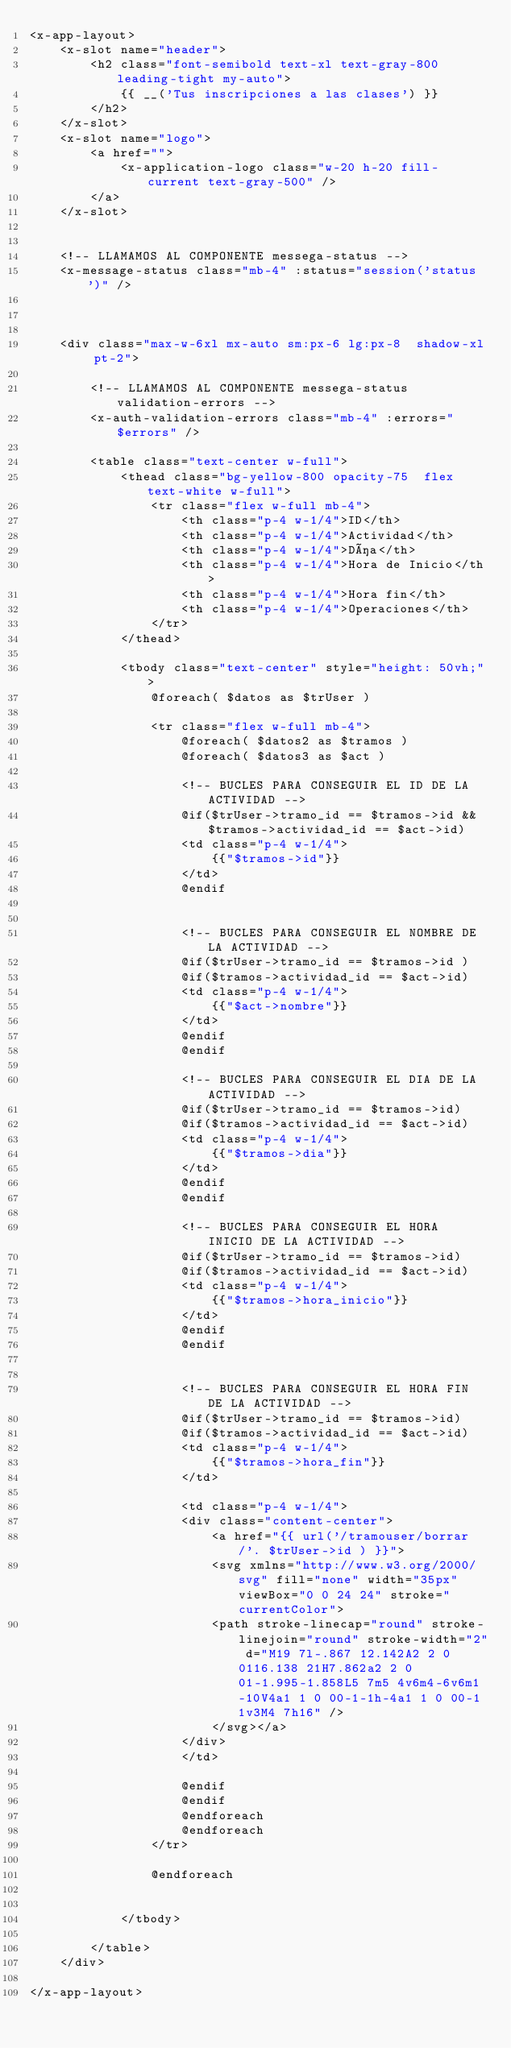Convert code to text. <code><loc_0><loc_0><loc_500><loc_500><_PHP_><x-app-layout>
    <x-slot name="header">
        <h2 class="font-semibold text-xl text-gray-800 leading-tight my-auto">
            {{ __('Tus inscripciones a las clases') }}
        </h2>
    </x-slot>
    <x-slot name="logo">
        <a href="">
            <x-application-logo class="w-20 h-20 fill-current text-gray-500" />
        </a>
    </x-slot>


    <!-- LLAMAMOS AL COMPONENTE messega-status -->
    <x-message-status class="mb-4" :status="session('status')" />
    
    

    <div class="max-w-6xl mx-auto sm:px-6 lg:px-8  shadow-xl pt-2">

        <!-- LLAMAMOS AL COMPONENTE messega-status validation-errors -->
        <x-auth-validation-errors class="mb-4" :errors="$errors" />

        <table class="text-center w-full">
            <thead class="bg-yellow-800 opacity-75  flex text-white w-full">
                <tr class="flex w-full mb-4">
                    <th class="p-4 w-1/4">ID</th>
                    <th class="p-4 w-1/4">Actividad</th>
                    <th class="p-4 w-1/4">Día</th>
                    <th class="p-4 w-1/4">Hora de Inicio</th>
                    <th class="p-4 w-1/4">Hora fin</th>
                    <th class="p-4 w-1/4">Operaciones</th>
                </tr>
            </thead>
            
            <tbody class="text-center" style="height: 50vh;">
                @foreach( $datos as $trUser )
                
                <tr class="flex w-full mb-4">
                    @foreach( $datos2 as $tramos )
                    @foreach( $datos3 as $act )

                    <!-- BUCLES PARA CONSEGUIR EL ID DE LA ACTIVIDAD -->
                    @if($trUser->tramo_id == $tramos->id && $tramos->actividad_id == $act->id)
                    <td class="p-4 w-1/4">
                        {{"$tramos->id"}}
                    </td>
                    @endif


                    <!-- BUCLES PARA CONSEGUIR EL NOMBRE DE LA ACTIVIDAD -->
                    @if($trUser->tramo_id == $tramos->id )
                    @if($tramos->actividad_id == $act->id)
                    <td class="p-4 w-1/4">
                        {{"$act->nombre"}}
                    </td>
                    @endif
                    @endif

                    <!-- BUCLES PARA CONSEGUIR EL DIA DE LA ACTIVIDAD -->
                    @if($trUser->tramo_id == $tramos->id)
                    @if($tramos->actividad_id == $act->id)
                    <td class="p-4 w-1/4">
                        {{"$tramos->dia"}}
                    </td>
                    @endif
                    @endif

                    <!-- BUCLES PARA CONSEGUIR EL HORA INICIO DE LA ACTIVIDAD -->
                    @if($trUser->tramo_id == $tramos->id)
                    @if($tramos->actividad_id == $act->id)
                    <td class="p-4 w-1/4">
                        {{"$tramos->hora_inicio"}}
                    </td>
                    @endif
                    @endif


                    <!-- BUCLES PARA CONSEGUIR EL HORA FIN DE LA ACTIVIDAD -->
                    @if($trUser->tramo_id == $tramos->id)
                    @if($tramos->actividad_id == $act->id)
                    <td class="p-4 w-1/4">
                        {{"$tramos->hora_fin"}}
                    </td>

                    <td class="p-4 w-1/4">
                    <div class="content-center">
                        <a href="{{ url('/tramouser/borrar/'. $trUser->id ) }}">
                        <svg xmlns="http://www.w3.org/2000/svg" fill="none" width="35px" viewBox="0 0 24 24" stroke="currentColor">
                        <path stroke-linecap="round" stroke-linejoin="round" stroke-width="2" d="M19 7l-.867 12.142A2 2 0 0116.138 21H7.862a2 2 0 01-1.995-1.858L5 7m5 4v6m4-6v6m1-10V4a1 1 0 00-1-1h-4a1 1 0 00-1 1v3M4 7h16" />
                        </svg></a>
                    </div>
                    </td>

                    @endif
                    @endif
                    @endforeach
                    @endforeach
                </tr>

                @endforeach


            </tbody>

        </table>
    </div>

</x-app-layout></code> 